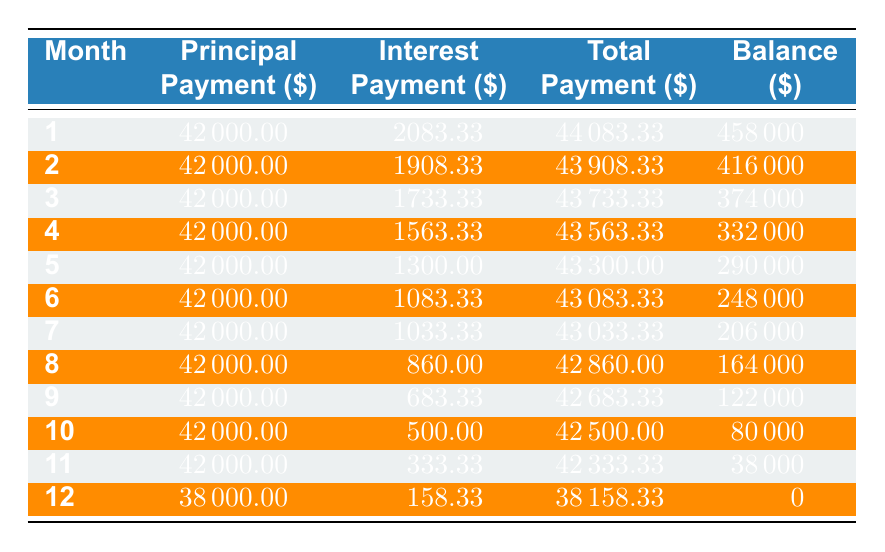What was the total payment made in month 5? In month 5, the total payment is clearly listed in the table as 43300.00.
Answer: 43300.00 How much was the principal payment in month 11? The principal payment for month 11 is specified in the table as 42000.00.
Answer: 42000.00 What is the remaining balance after the payment in month 3? The table shows that after the payment in month 3, the remaining balance is 374000.
Answer: 374000 Is the interest payment for month 8 greater than the interest payment for month 7? The interest payment for month 8 is 860.00, and for month 7, it is 1033.33. Since 860.00 is less than 1033.33, the statement is false.
Answer: No What is the total amount paid by the end of the loan term? To find the total amount paid by the end of the loan, we sum up all the total payments for each month: (44083.33 + 43908.33 + 43733.33 + 43563.33 + 43300.00 + 43083.33 + 43033.33 + 42860.00 + 42683.33 + 42500.00 + 42333.33 + 38158.33) = 519000.00.
Answer: 519000.00 What was the largest total payment in any month? By reviewing the total payment column, the largest total payment is in month 1, which is 44083.33.
Answer: 44083.33 If the loan continues for another month, how much would be the expected principal payment? The principal payment for months 1 through 11 has been consistently 42000. Therefore, it is reasonable to expect the principal payment for the next month would also be around 42000.00, except for the last month where it was lower due to the decreasing balance.
Answer: 42000.00 Was there any month where the interest payment was less than 500.00? Yes, the interest payment for month 10 (500.00) is the threshold, and month 11 (333.33) and month 12 (158.33) both have amounts below this threshold.
Answer: Yes What is the average interest payment over the entire loan period? To find the average interest payment, we sum all interest payments (2083.33 + 1908.33 + 1733.33 + 1563.33 + 1300.00 + 1083.33 + 1033.33 + 860.00 + 683.33 + 500.00 + 333.33 + 158.33) = 13283.00, then divide by 12 (the number of months) gives us 1106.92.
Answer: 1106.92 